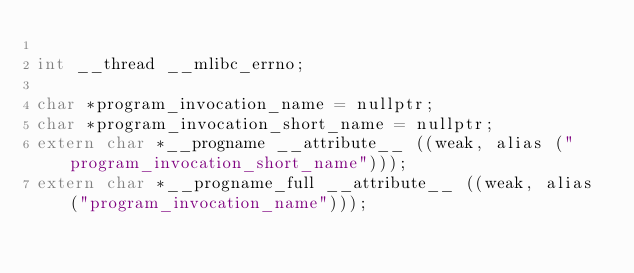Convert code to text. <code><loc_0><loc_0><loc_500><loc_500><_C++_>
int __thread __mlibc_errno;

char *program_invocation_name = nullptr;
char *program_invocation_short_name = nullptr;
extern char *__progname __attribute__ ((weak, alias ("program_invocation_short_name")));
extern char *__progname_full __attribute__ ((weak, alias ("program_invocation_name")));

</code> 